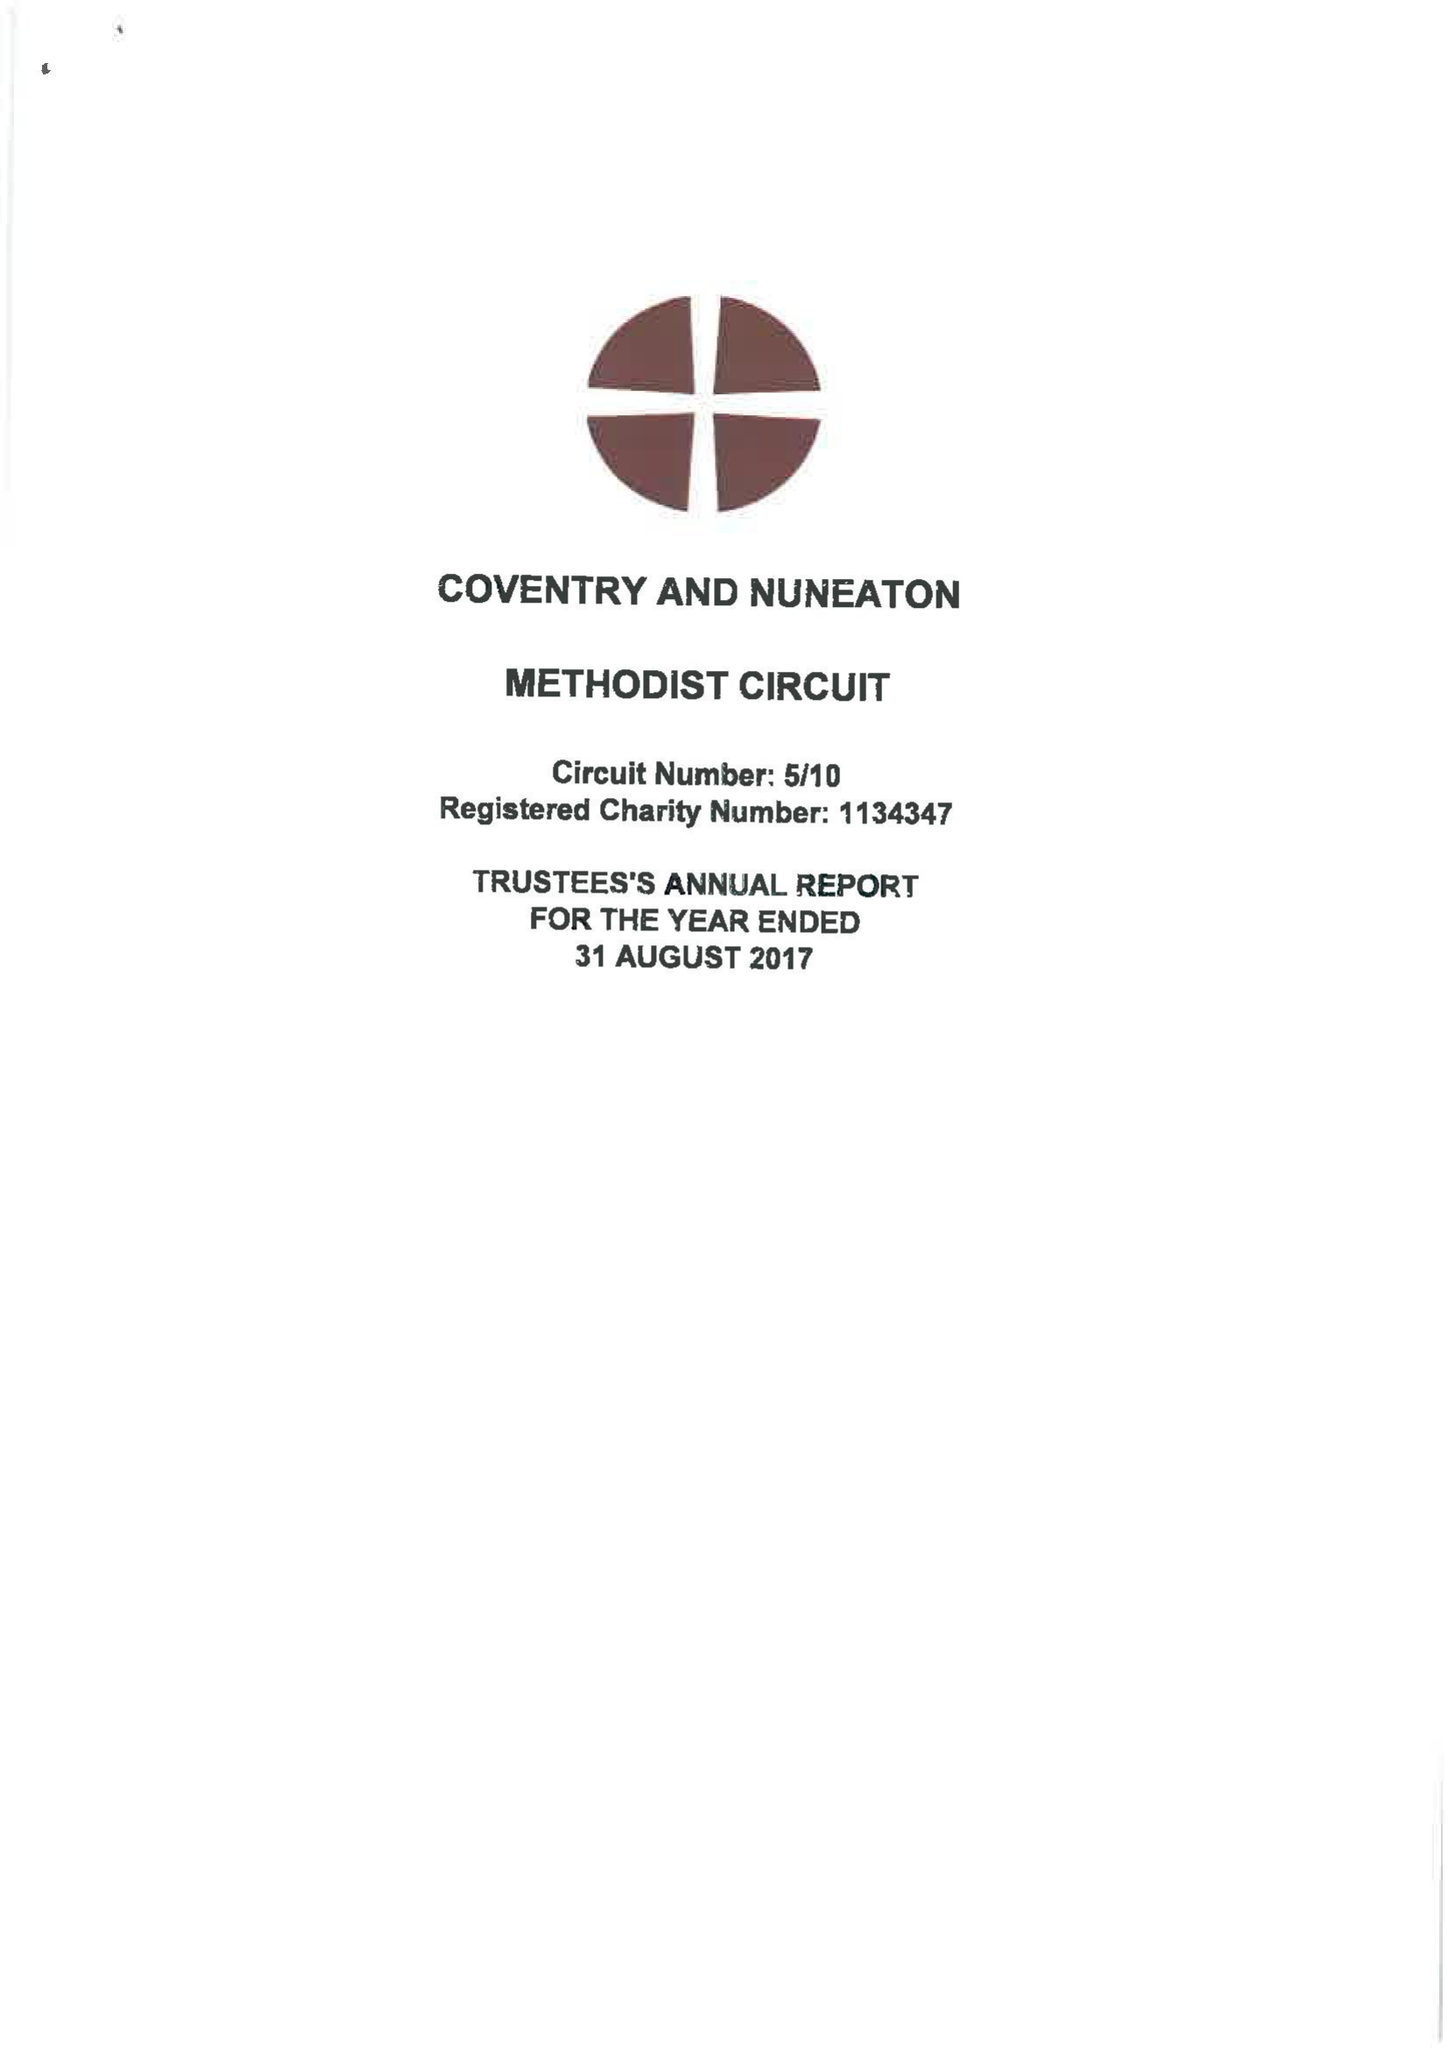What is the value for the charity_number?
Answer the question using a single word or phrase. 1134347 